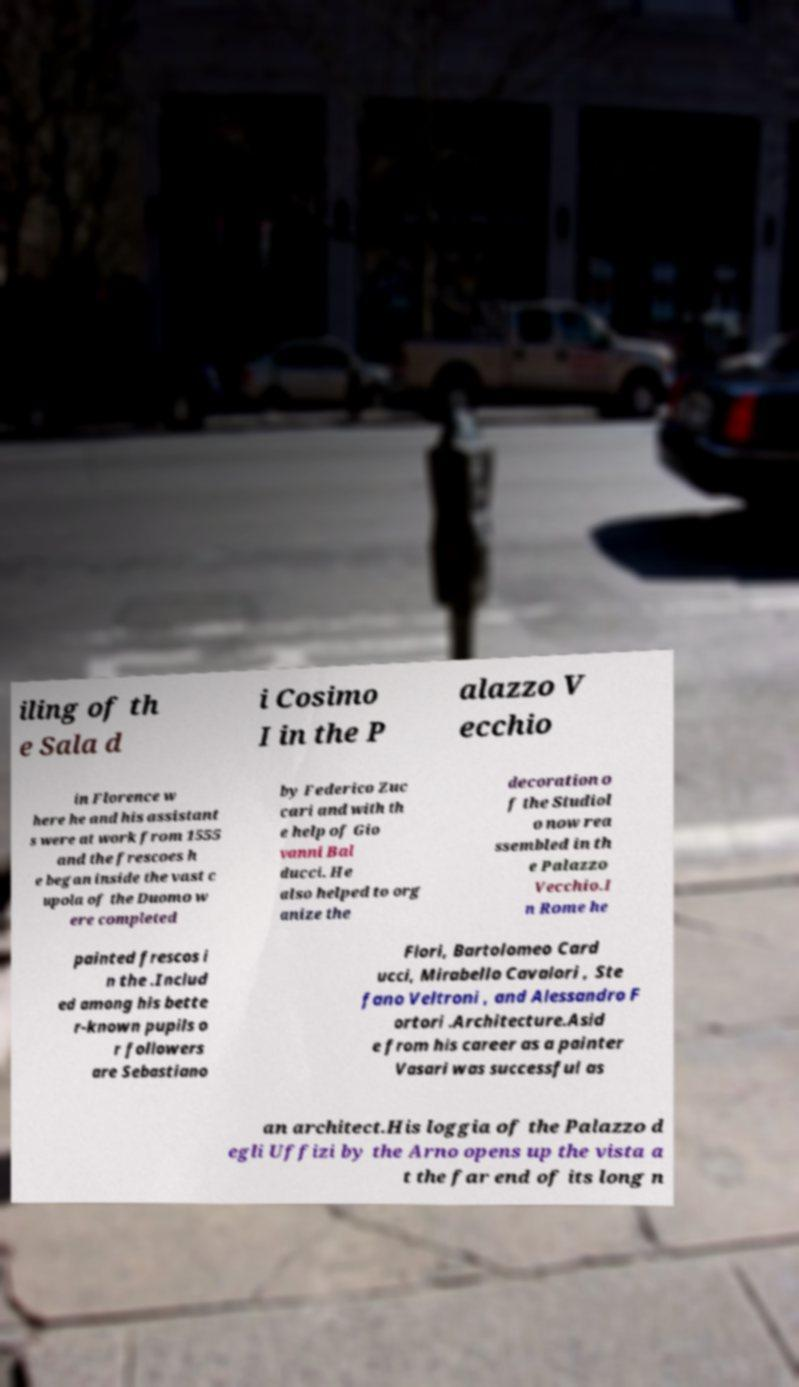Please read and relay the text visible in this image. What does it say? iling of th e Sala d i Cosimo I in the P alazzo V ecchio in Florence w here he and his assistant s were at work from 1555 and the frescoes h e began inside the vast c upola of the Duomo w ere completed by Federico Zuc cari and with th e help of Gio vanni Bal ducci. He also helped to org anize the decoration o f the Studiol o now rea ssembled in th e Palazzo Vecchio.I n Rome he painted frescos i n the .Includ ed among his bette r-known pupils o r followers are Sebastiano Flori, Bartolomeo Card ucci, Mirabello Cavalori , Ste fano Veltroni , and Alessandro F ortori .Architecture.Asid e from his career as a painter Vasari was successful as an architect.His loggia of the Palazzo d egli Uffizi by the Arno opens up the vista a t the far end of its long n 